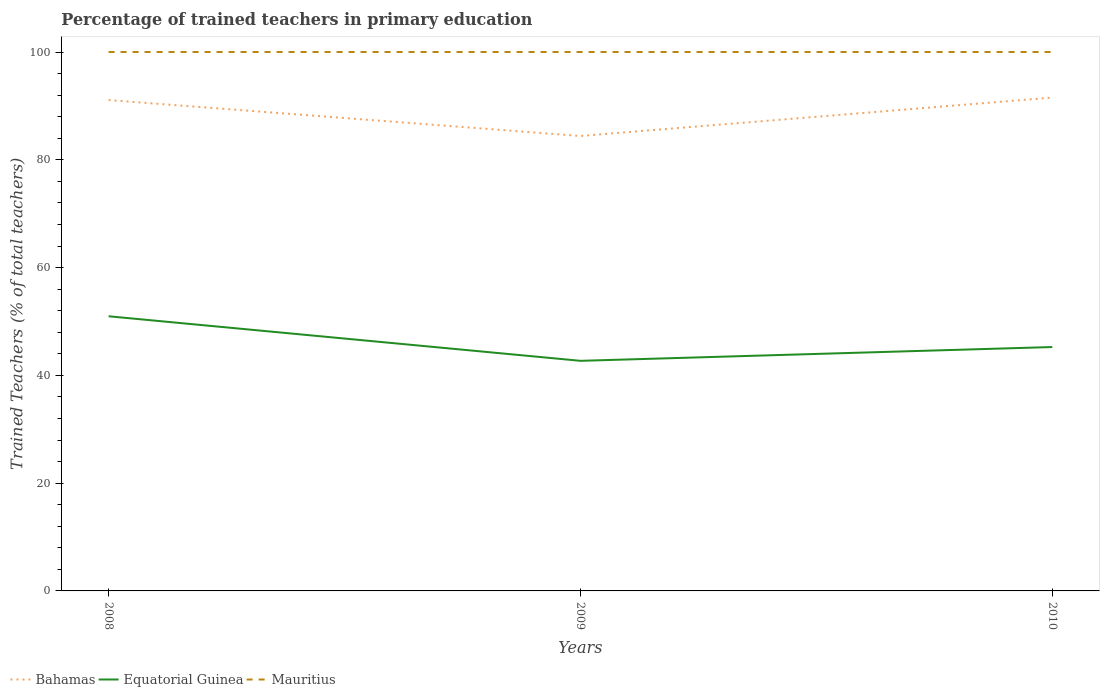How many different coloured lines are there?
Offer a very short reply. 3. Does the line corresponding to Equatorial Guinea intersect with the line corresponding to Bahamas?
Your answer should be very brief. No. Across all years, what is the maximum percentage of trained teachers in Equatorial Guinea?
Give a very brief answer. 42.7. In which year was the percentage of trained teachers in Bahamas maximum?
Keep it short and to the point. 2009. What is the total percentage of trained teachers in Bahamas in the graph?
Your answer should be very brief. -0.46. What is the difference between the highest and the second highest percentage of trained teachers in Mauritius?
Your answer should be very brief. 0. Is the percentage of trained teachers in Equatorial Guinea strictly greater than the percentage of trained teachers in Bahamas over the years?
Ensure brevity in your answer.  Yes. How many lines are there?
Offer a terse response. 3. What is the difference between two consecutive major ticks on the Y-axis?
Your answer should be compact. 20. Are the values on the major ticks of Y-axis written in scientific E-notation?
Offer a terse response. No. Does the graph contain grids?
Ensure brevity in your answer.  No. Where does the legend appear in the graph?
Your answer should be very brief. Bottom left. How are the legend labels stacked?
Provide a succinct answer. Horizontal. What is the title of the graph?
Your response must be concise. Percentage of trained teachers in primary education. What is the label or title of the Y-axis?
Give a very brief answer. Trained Teachers (% of total teachers). What is the Trained Teachers (% of total teachers) of Bahamas in 2008?
Ensure brevity in your answer.  91.08. What is the Trained Teachers (% of total teachers) of Equatorial Guinea in 2008?
Provide a succinct answer. 50.97. What is the Trained Teachers (% of total teachers) in Bahamas in 2009?
Keep it short and to the point. 84.42. What is the Trained Teachers (% of total teachers) of Equatorial Guinea in 2009?
Give a very brief answer. 42.7. What is the Trained Teachers (% of total teachers) of Bahamas in 2010?
Your answer should be compact. 91.55. What is the Trained Teachers (% of total teachers) of Equatorial Guinea in 2010?
Keep it short and to the point. 45.26. What is the Trained Teachers (% of total teachers) in Mauritius in 2010?
Offer a terse response. 100. Across all years, what is the maximum Trained Teachers (% of total teachers) in Bahamas?
Your answer should be very brief. 91.55. Across all years, what is the maximum Trained Teachers (% of total teachers) of Equatorial Guinea?
Make the answer very short. 50.97. Across all years, what is the maximum Trained Teachers (% of total teachers) of Mauritius?
Make the answer very short. 100. Across all years, what is the minimum Trained Teachers (% of total teachers) in Bahamas?
Provide a short and direct response. 84.42. Across all years, what is the minimum Trained Teachers (% of total teachers) of Equatorial Guinea?
Offer a terse response. 42.7. Across all years, what is the minimum Trained Teachers (% of total teachers) in Mauritius?
Ensure brevity in your answer.  100. What is the total Trained Teachers (% of total teachers) of Bahamas in the graph?
Make the answer very short. 267.05. What is the total Trained Teachers (% of total teachers) in Equatorial Guinea in the graph?
Your response must be concise. 138.92. What is the total Trained Teachers (% of total teachers) of Mauritius in the graph?
Provide a succinct answer. 300. What is the difference between the Trained Teachers (% of total teachers) of Bahamas in 2008 and that in 2009?
Ensure brevity in your answer.  6.66. What is the difference between the Trained Teachers (% of total teachers) of Equatorial Guinea in 2008 and that in 2009?
Provide a short and direct response. 8.27. What is the difference between the Trained Teachers (% of total teachers) of Bahamas in 2008 and that in 2010?
Provide a succinct answer. -0.46. What is the difference between the Trained Teachers (% of total teachers) of Equatorial Guinea in 2008 and that in 2010?
Provide a succinct answer. 5.71. What is the difference between the Trained Teachers (% of total teachers) in Mauritius in 2008 and that in 2010?
Offer a very short reply. 0. What is the difference between the Trained Teachers (% of total teachers) of Bahamas in 2009 and that in 2010?
Provide a succinct answer. -7.13. What is the difference between the Trained Teachers (% of total teachers) of Equatorial Guinea in 2009 and that in 2010?
Ensure brevity in your answer.  -2.56. What is the difference between the Trained Teachers (% of total teachers) in Mauritius in 2009 and that in 2010?
Your answer should be compact. 0. What is the difference between the Trained Teachers (% of total teachers) in Bahamas in 2008 and the Trained Teachers (% of total teachers) in Equatorial Guinea in 2009?
Keep it short and to the point. 48.39. What is the difference between the Trained Teachers (% of total teachers) of Bahamas in 2008 and the Trained Teachers (% of total teachers) of Mauritius in 2009?
Make the answer very short. -8.92. What is the difference between the Trained Teachers (% of total teachers) of Equatorial Guinea in 2008 and the Trained Teachers (% of total teachers) of Mauritius in 2009?
Your answer should be compact. -49.03. What is the difference between the Trained Teachers (% of total teachers) in Bahamas in 2008 and the Trained Teachers (% of total teachers) in Equatorial Guinea in 2010?
Your answer should be very brief. 45.83. What is the difference between the Trained Teachers (% of total teachers) of Bahamas in 2008 and the Trained Teachers (% of total teachers) of Mauritius in 2010?
Your answer should be compact. -8.92. What is the difference between the Trained Teachers (% of total teachers) of Equatorial Guinea in 2008 and the Trained Teachers (% of total teachers) of Mauritius in 2010?
Keep it short and to the point. -49.03. What is the difference between the Trained Teachers (% of total teachers) of Bahamas in 2009 and the Trained Teachers (% of total teachers) of Equatorial Guinea in 2010?
Keep it short and to the point. 39.16. What is the difference between the Trained Teachers (% of total teachers) in Bahamas in 2009 and the Trained Teachers (% of total teachers) in Mauritius in 2010?
Ensure brevity in your answer.  -15.58. What is the difference between the Trained Teachers (% of total teachers) in Equatorial Guinea in 2009 and the Trained Teachers (% of total teachers) in Mauritius in 2010?
Your answer should be very brief. -57.3. What is the average Trained Teachers (% of total teachers) in Bahamas per year?
Your response must be concise. 89.02. What is the average Trained Teachers (% of total teachers) of Equatorial Guinea per year?
Your answer should be compact. 46.31. What is the average Trained Teachers (% of total teachers) in Mauritius per year?
Your answer should be very brief. 100. In the year 2008, what is the difference between the Trained Teachers (% of total teachers) in Bahamas and Trained Teachers (% of total teachers) in Equatorial Guinea?
Offer a very short reply. 40.12. In the year 2008, what is the difference between the Trained Teachers (% of total teachers) in Bahamas and Trained Teachers (% of total teachers) in Mauritius?
Make the answer very short. -8.92. In the year 2008, what is the difference between the Trained Teachers (% of total teachers) of Equatorial Guinea and Trained Teachers (% of total teachers) of Mauritius?
Ensure brevity in your answer.  -49.03. In the year 2009, what is the difference between the Trained Teachers (% of total teachers) of Bahamas and Trained Teachers (% of total teachers) of Equatorial Guinea?
Make the answer very short. 41.72. In the year 2009, what is the difference between the Trained Teachers (% of total teachers) in Bahamas and Trained Teachers (% of total teachers) in Mauritius?
Make the answer very short. -15.58. In the year 2009, what is the difference between the Trained Teachers (% of total teachers) in Equatorial Guinea and Trained Teachers (% of total teachers) in Mauritius?
Provide a succinct answer. -57.3. In the year 2010, what is the difference between the Trained Teachers (% of total teachers) in Bahamas and Trained Teachers (% of total teachers) in Equatorial Guinea?
Offer a terse response. 46.29. In the year 2010, what is the difference between the Trained Teachers (% of total teachers) in Bahamas and Trained Teachers (% of total teachers) in Mauritius?
Provide a succinct answer. -8.45. In the year 2010, what is the difference between the Trained Teachers (% of total teachers) in Equatorial Guinea and Trained Teachers (% of total teachers) in Mauritius?
Your answer should be compact. -54.74. What is the ratio of the Trained Teachers (% of total teachers) of Bahamas in 2008 to that in 2009?
Offer a terse response. 1.08. What is the ratio of the Trained Teachers (% of total teachers) of Equatorial Guinea in 2008 to that in 2009?
Your answer should be very brief. 1.19. What is the ratio of the Trained Teachers (% of total teachers) of Mauritius in 2008 to that in 2009?
Offer a terse response. 1. What is the ratio of the Trained Teachers (% of total teachers) in Equatorial Guinea in 2008 to that in 2010?
Your answer should be very brief. 1.13. What is the ratio of the Trained Teachers (% of total teachers) of Mauritius in 2008 to that in 2010?
Keep it short and to the point. 1. What is the ratio of the Trained Teachers (% of total teachers) of Bahamas in 2009 to that in 2010?
Give a very brief answer. 0.92. What is the ratio of the Trained Teachers (% of total teachers) of Equatorial Guinea in 2009 to that in 2010?
Your answer should be very brief. 0.94. What is the ratio of the Trained Teachers (% of total teachers) of Mauritius in 2009 to that in 2010?
Your answer should be compact. 1. What is the difference between the highest and the second highest Trained Teachers (% of total teachers) in Bahamas?
Your answer should be compact. 0.46. What is the difference between the highest and the second highest Trained Teachers (% of total teachers) of Equatorial Guinea?
Offer a terse response. 5.71. What is the difference between the highest and the lowest Trained Teachers (% of total teachers) in Bahamas?
Keep it short and to the point. 7.13. What is the difference between the highest and the lowest Trained Teachers (% of total teachers) in Equatorial Guinea?
Your response must be concise. 8.27. 